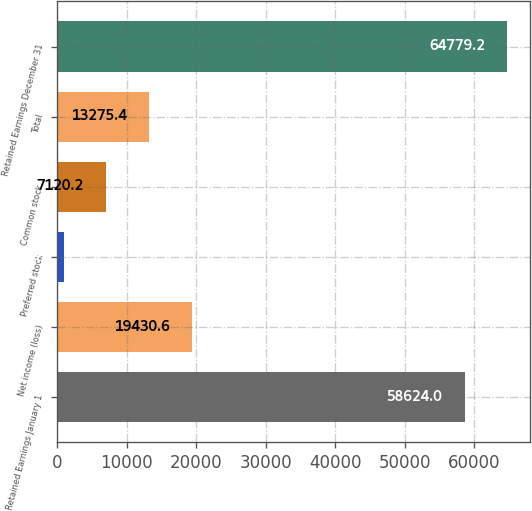Convert chart to OTSL. <chart><loc_0><loc_0><loc_500><loc_500><bar_chart><fcel>Retained Earnings January 1<fcel>Net income (loss)<fcel>Preferred stock<fcel>Common stock<fcel>Total<fcel>Retained Earnings December 31<nl><fcel>58624<fcel>19430.6<fcel>965<fcel>7120.2<fcel>13275.4<fcel>64779.2<nl></chart> 